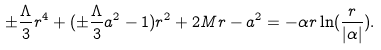<formula> <loc_0><loc_0><loc_500><loc_500>\pm \frac { \Lambda } { 3 } r ^ { 4 } + ( \pm \frac { \Lambda } { 3 } a ^ { 2 } - 1 ) r ^ { 2 } + 2 M r - a ^ { 2 } = - \alpha r \ln ( \frac { r } { | \alpha | } ) .</formula> 